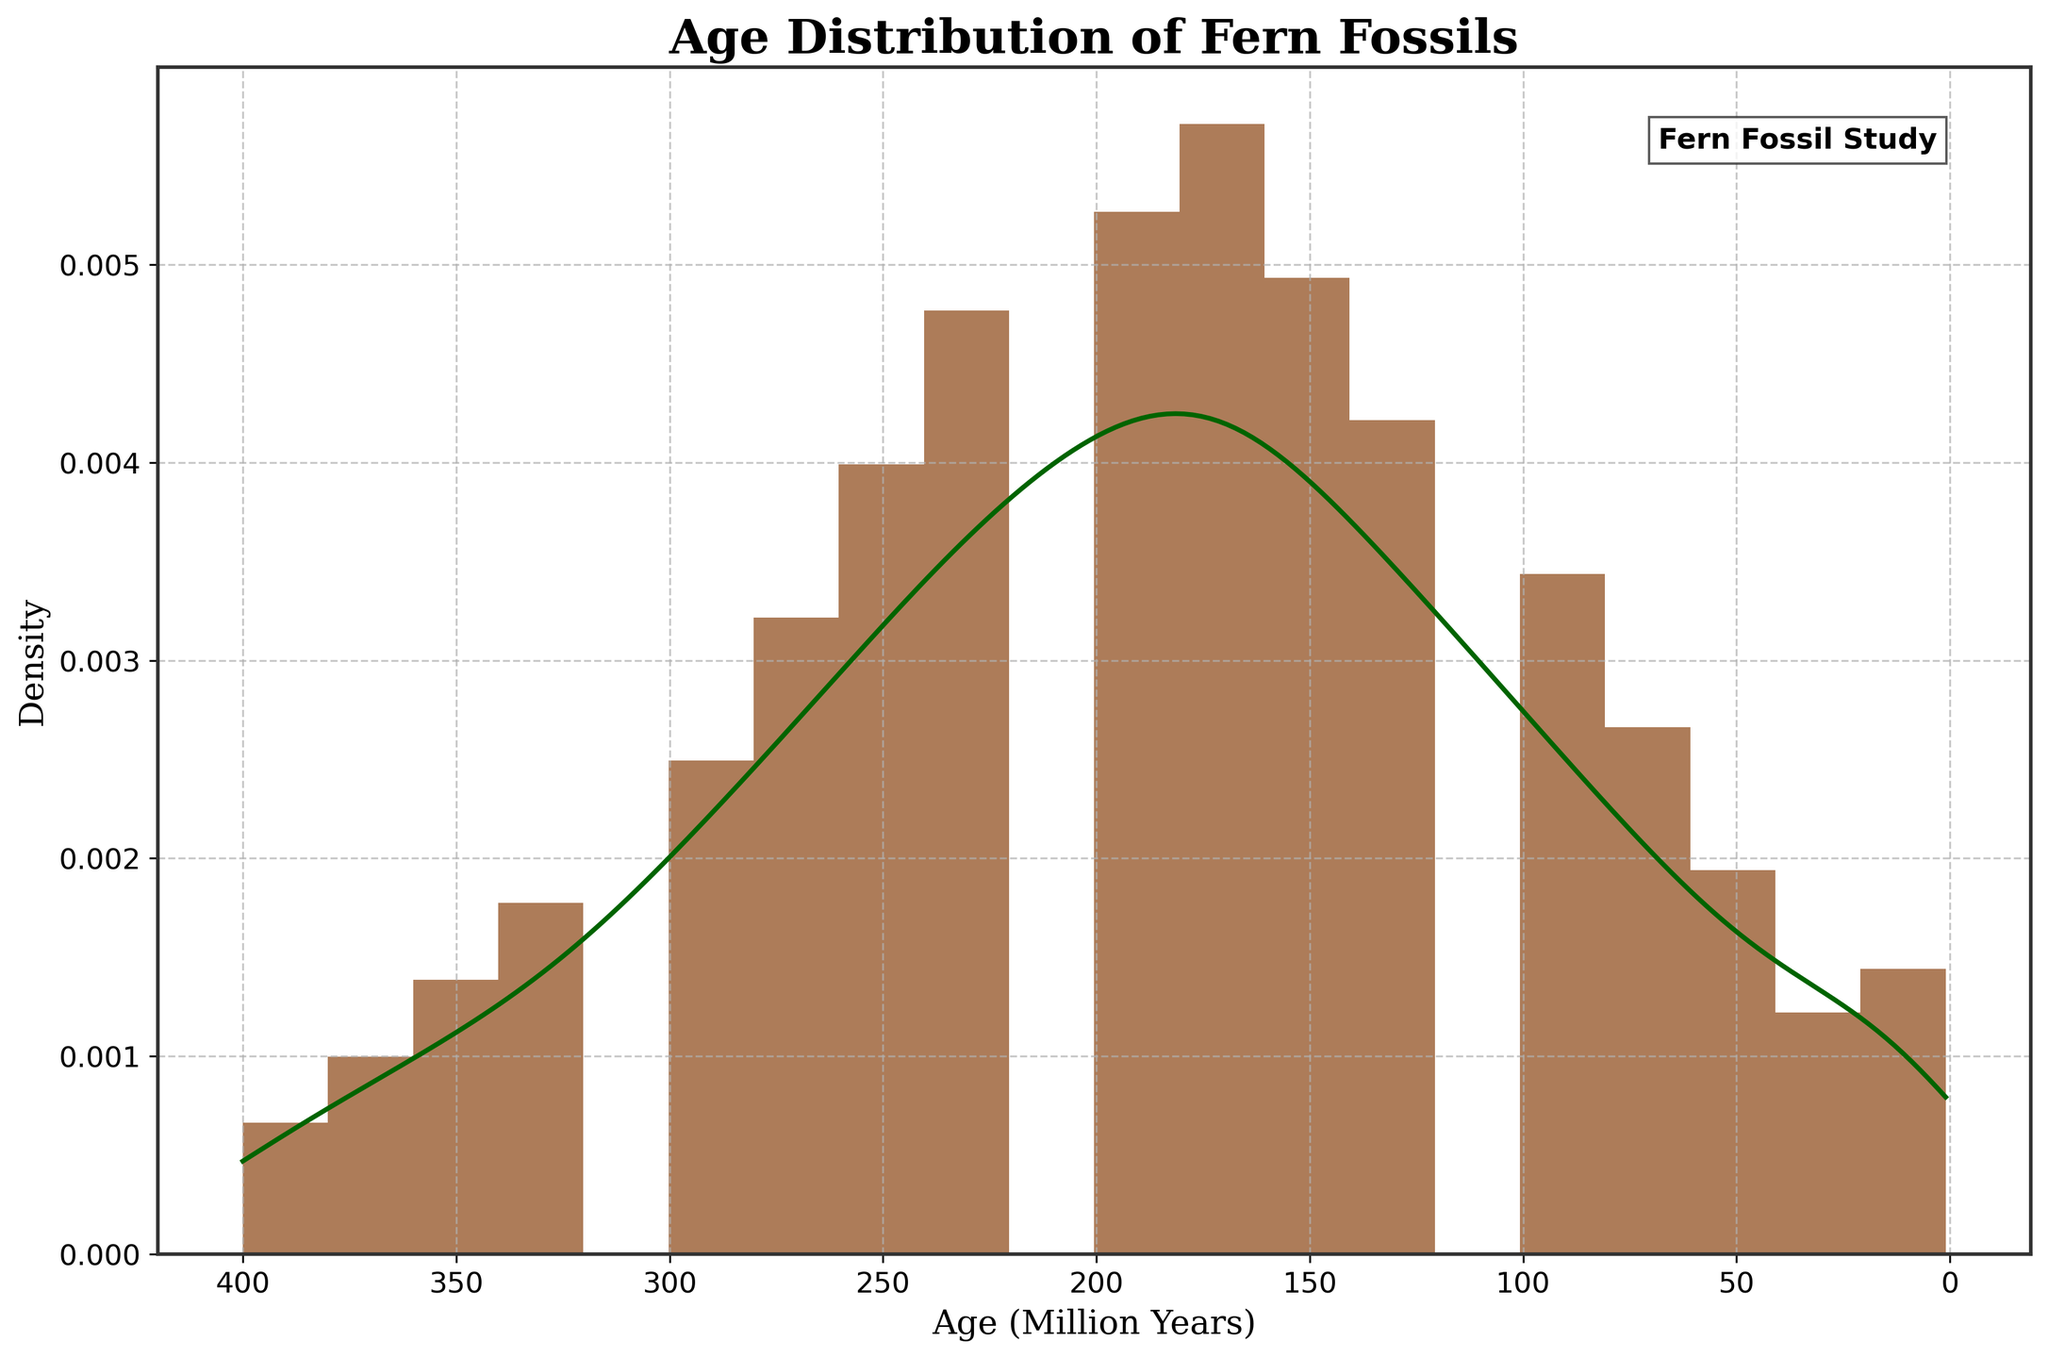What's the title of the figure? The title is located at the top of the figure and is "Age Distribution of Fern Fossils".
Answer: Age Distribution of Fern Fossils What does the x-axis represent? The x-axis represents the age of fern fossils in millions of years, which is shown directly below the axis label.
Answer: Age (Million Years) What does the y-axis represent? The y-axis represents the density of the fossil count, as indicated by the y-axis label "Density".
Answer: Density What information does the KDE (density curve) provide compared to the histogram? The KDE (density curve) provides a smoothed estimate of the distribution of data, showing the density where fern fossils were most and least prevalent, while the histogram displays the count-based frequency distribution of the same data.
Answer: Smoothed density estimate What era had the highest density of fern fossils? By observing the peak of the KDE curve, the highest density of fern fossils appears around the 175 million years mark.
Answer: Around 175 million years Compare the density of fern fossils at 200 million years to 100 million years. At 200 million years, the density of fern fossils is higher compared to 100 million years, as indicated by the KDE curve being higher at 200 million years than at 100 million years.
Answer: Higher at 200 million years What pattern is observed in the density of fern fossils from 400 to 1 million years? The density of fern fossils initially increases as we move from 400 million years towards 175 million years, then shows a decreasing trend from that point onwards up to 1 million years.
Answer: Initial increase, then decrease Why is the x-axis of the figure inverted? The x-axis is inverted to show older ages on the right and more recent ages on the left, aiding in the understanding of historical patterns and emphasizing the ancient origins and gradual decline of fer species.
Answer: To show older ages on the right What is indicated by the grid and the customized spines in the figure? The grid and the customized spines (solid lines surrounding the plot area) help provide clearer visualization and reference points for examining the data distribution, making it easier to identify peaks and trends.
Answer: Clearer visualization and reference points 